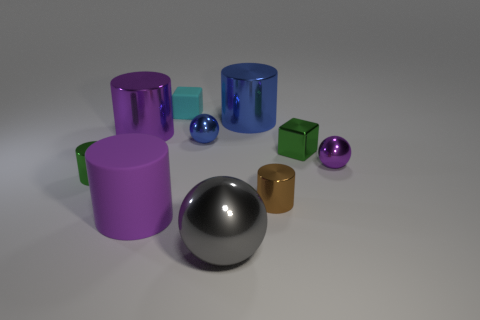Subtract all blue cylinders. How many cylinders are left? 4 Subtract all green shiny cylinders. How many cylinders are left? 4 Subtract all yellow cylinders. Subtract all yellow spheres. How many cylinders are left? 5 Subtract all blocks. How many objects are left? 8 Add 3 big gray metal objects. How many big gray metal objects are left? 4 Add 1 purple matte objects. How many purple matte objects exist? 2 Subtract 0 red cubes. How many objects are left? 10 Subtract all tiny green blocks. Subtract all tiny cubes. How many objects are left? 7 